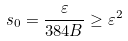Convert formula to latex. <formula><loc_0><loc_0><loc_500><loc_500>s _ { 0 } = \frac { \varepsilon } { 3 8 4 B } \geq \varepsilon ^ { 2 }</formula> 